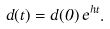Convert formula to latex. <formula><loc_0><loc_0><loc_500><loc_500>d ( t ) = d ( 0 ) \, e ^ { h t } .</formula> 